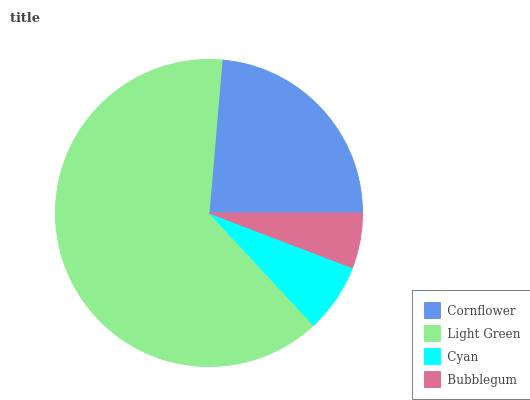Is Bubblegum the minimum?
Answer yes or no. Yes. Is Light Green the maximum?
Answer yes or no. Yes. Is Cyan the minimum?
Answer yes or no. No. Is Cyan the maximum?
Answer yes or no. No. Is Light Green greater than Cyan?
Answer yes or no. Yes. Is Cyan less than Light Green?
Answer yes or no. Yes. Is Cyan greater than Light Green?
Answer yes or no. No. Is Light Green less than Cyan?
Answer yes or no. No. Is Cornflower the high median?
Answer yes or no. Yes. Is Cyan the low median?
Answer yes or no. Yes. Is Cyan the high median?
Answer yes or no. No. Is Light Green the low median?
Answer yes or no. No. 